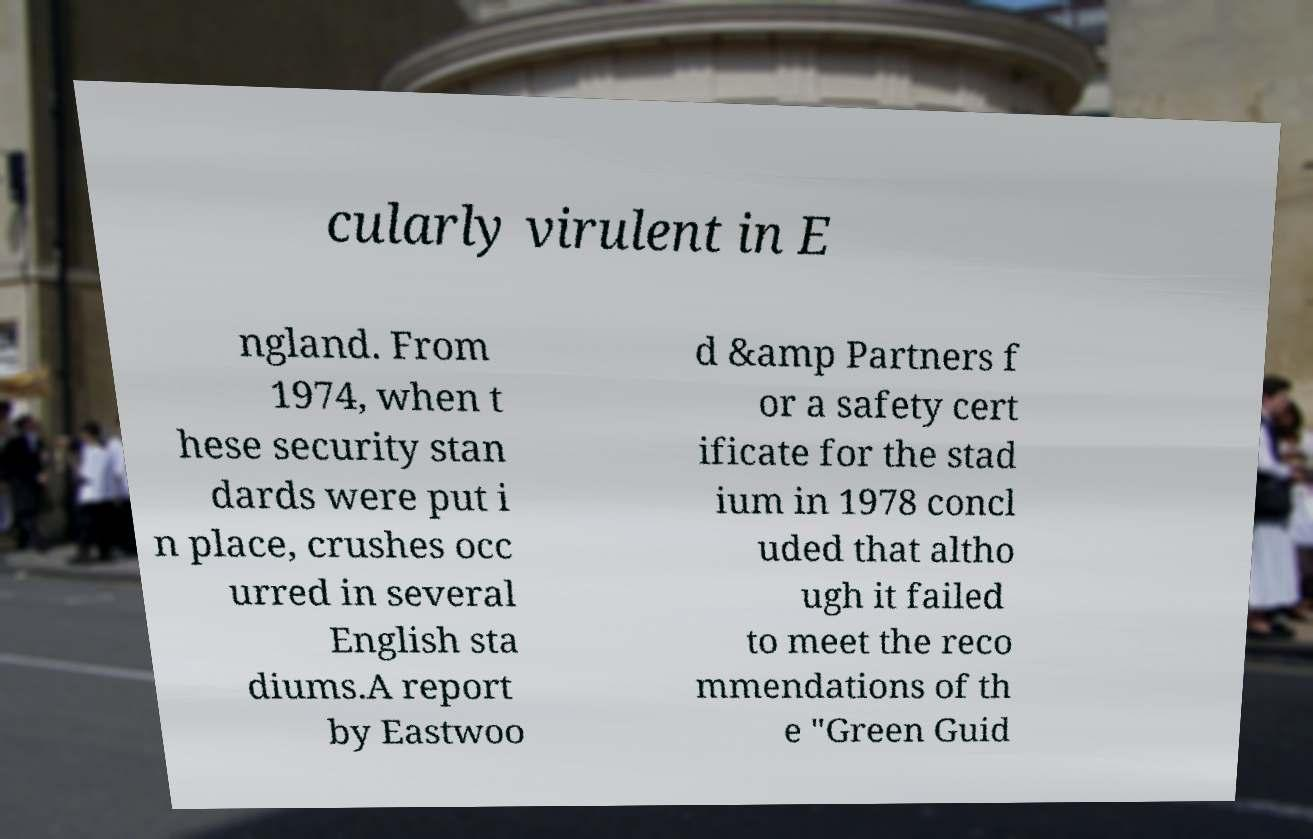Please read and relay the text visible in this image. What does it say? cularly virulent in E ngland. From 1974, when t hese security stan dards were put i n place, crushes occ urred in several English sta diums.A report by Eastwoo d &amp Partners f or a safety cert ificate for the stad ium in 1978 concl uded that altho ugh it failed to meet the reco mmendations of th e "Green Guid 